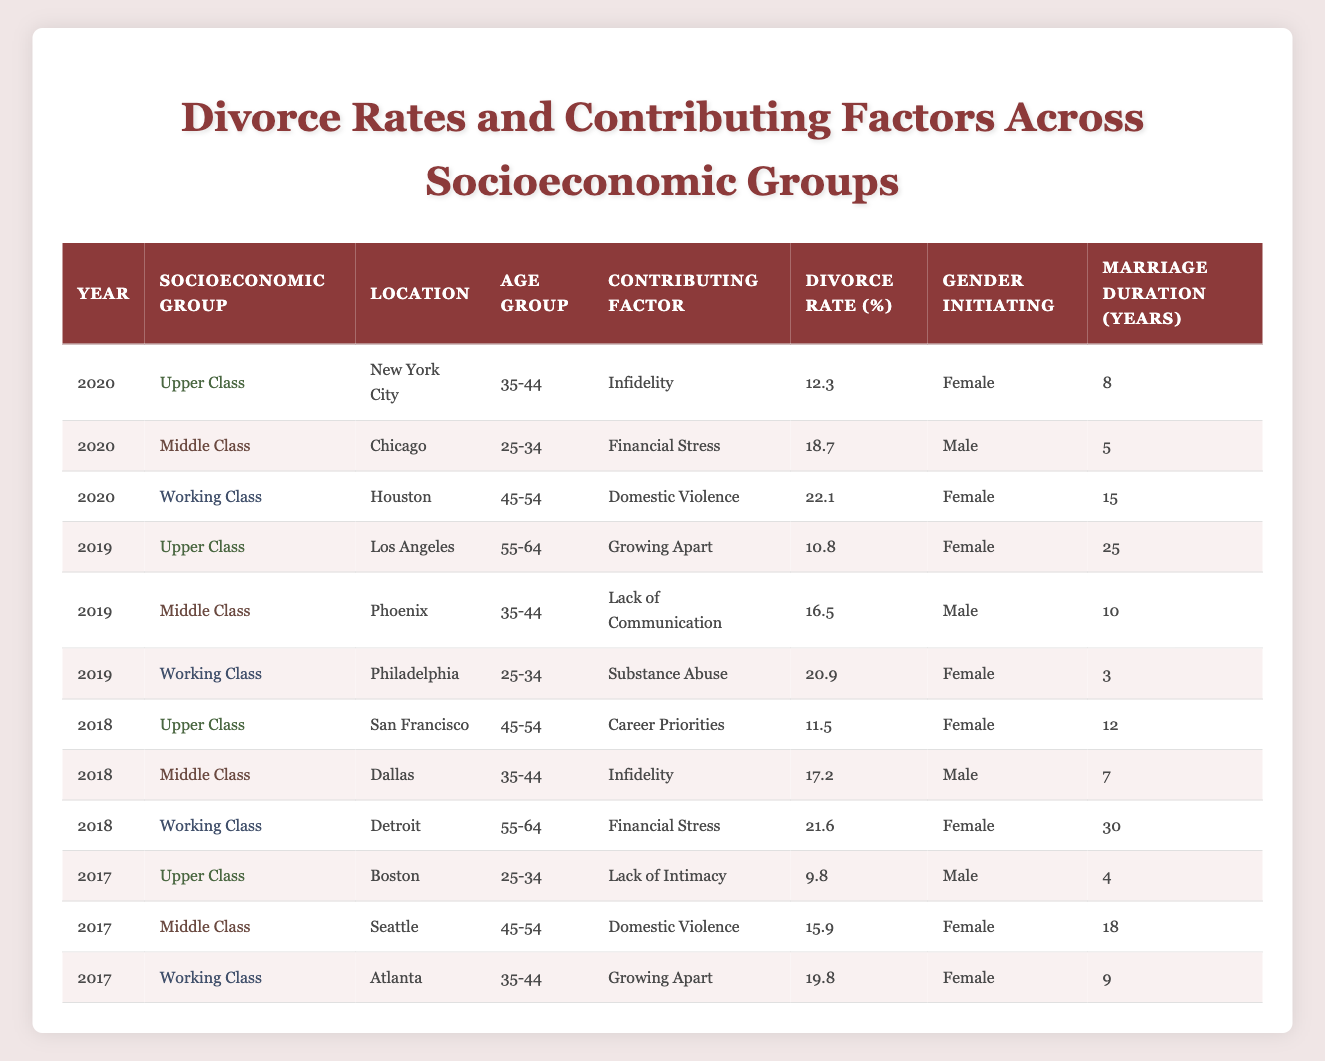What is the highest divorce rate recorded in the table? The highest divorce rate in the table is found in the 2020 Working Class group from Houston with a rate of 22.1.
Answer: 22.1 Which socioeconomic group had the lowest divorce rate in 2019? In 2019, the Upper Class group had the lowest divorce rate at 10.8.
Answer: 10.8 What is the average marriage duration for the Middle Class group across all years? The marriage durations for the Middle Class group are 5, 10, and 18 years. The average is calculated by summing these durations (5 + 10 + 18 = 33) and dividing by the number of entries (3), giving 33 / 3 = 11.
Answer: 11 Did any Female-initiated divorces have a divorce rate over 20% in 2020? Yes, the divorce initiated by a female in the Working Class group in Houston had a divorce rate of 22.1%, which is over 20%.
Answer: Yes How many different contributing factors are mentioned in the table? The contributing factors listed in the table are: Infidelity, Financial Stress, Domestic Violence, Growing Apart, Lack of Communication, Substance Abuse, Career Priorities, and Lack of Intimacy. This totals to 8 different factors.
Answer: 8 For the year 2018, what was the average divorce rate for the Upper Class? The divorce rates for the Upper Class in 2018 were 11.5. Therefore, the average, being a single entry, is 11.5 itself.
Answer: 11.5 Is the overall trend in divorce rates for the Working Class group increasing over the years represented? Yes, the divorce rates for the Working Class group are 19.8, then 20.9, and finally 22.1, indicating an increase.
Answer: Yes Which age group shows the highest divorce rate in the Working Class from the table? The age group of 45-54 shows the highest divorce rate in the Working Class group with a rate of 22.1 recorded in 2020.
Answer: 45-54 What percentage of divorces in 2019 were due to Domestic Violence among the socio-economic groups? In 2019, the Working Class had a divorce rate of 20.9 for the contributing factor of Substance Abuse, and the Middle Class had a rate of 15.9 for Domestic Violence. There was only one instance in the Working Class reflecting Domestic Violence, making it a percentage of 15.9.
Answer: 15.9 